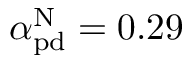<formula> <loc_0><loc_0><loc_500><loc_500>\alpha _ { p d } ^ { N } = 0 . 2 9</formula> 